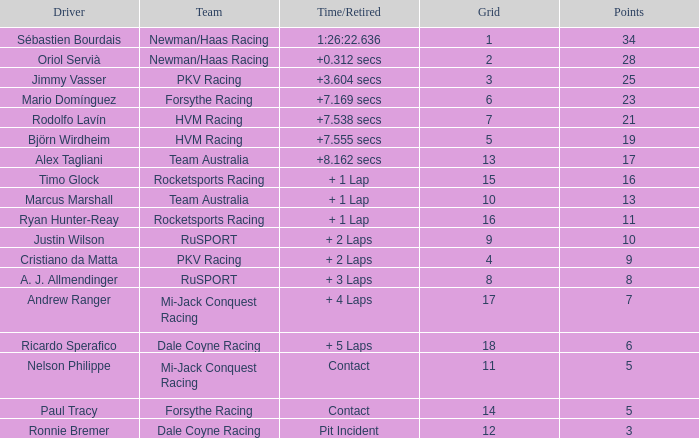What is ryan hunter-reay's average points tally? 11.0. 